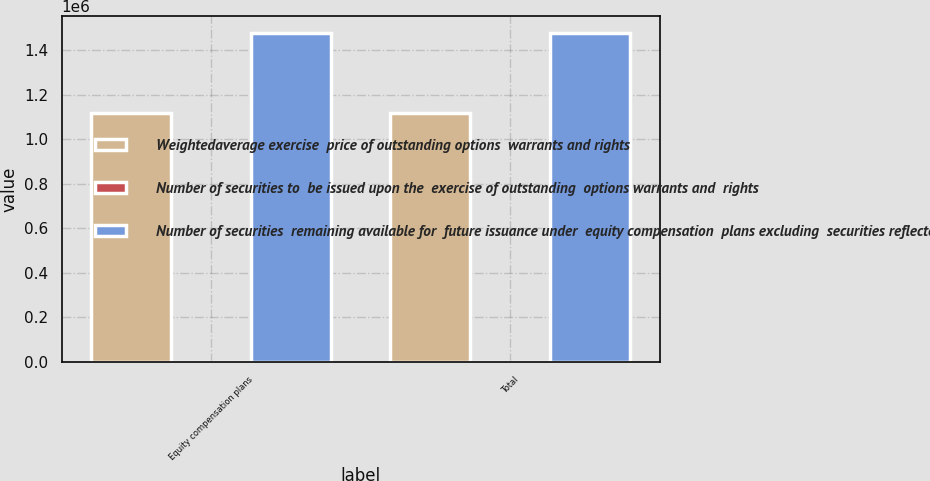Convert chart. <chart><loc_0><loc_0><loc_500><loc_500><stacked_bar_chart><ecel><fcel>Equity compensation plans<fcel>Total<nl><fcel>Weightedaverage exercise  price of outstanding options  warrants and rights<fcel>1.11743e+06<fcel>1.11743e+06<nl><fcel>Number of securities to  be issued upon the  exercise of outstanding  options warrants and  rights<fcel>27.01<fcel>27.01<nl><fcel>Number of securities  remaining available for  future issuance under  equity compensation  plans excluding  securities reflected in  the first column<fcel>1.47889e+06<fcel>1.47889e+06<nl></chart> 